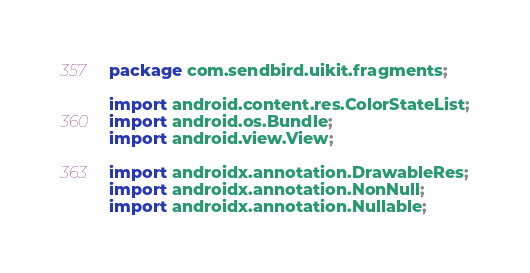Convert code to text. <code><loc_0><loc_0><loc_500><loc_500><_Java_>package com.sendbird.uikit.fragments;

import android.content.res.ColorStateList;
import android.os.Bundle;
import android.view.View;

import androidx.annotation.DrawableRes;
import androidx.annotation.NonNull;
import androidx.annotation.Nullable;</code> 